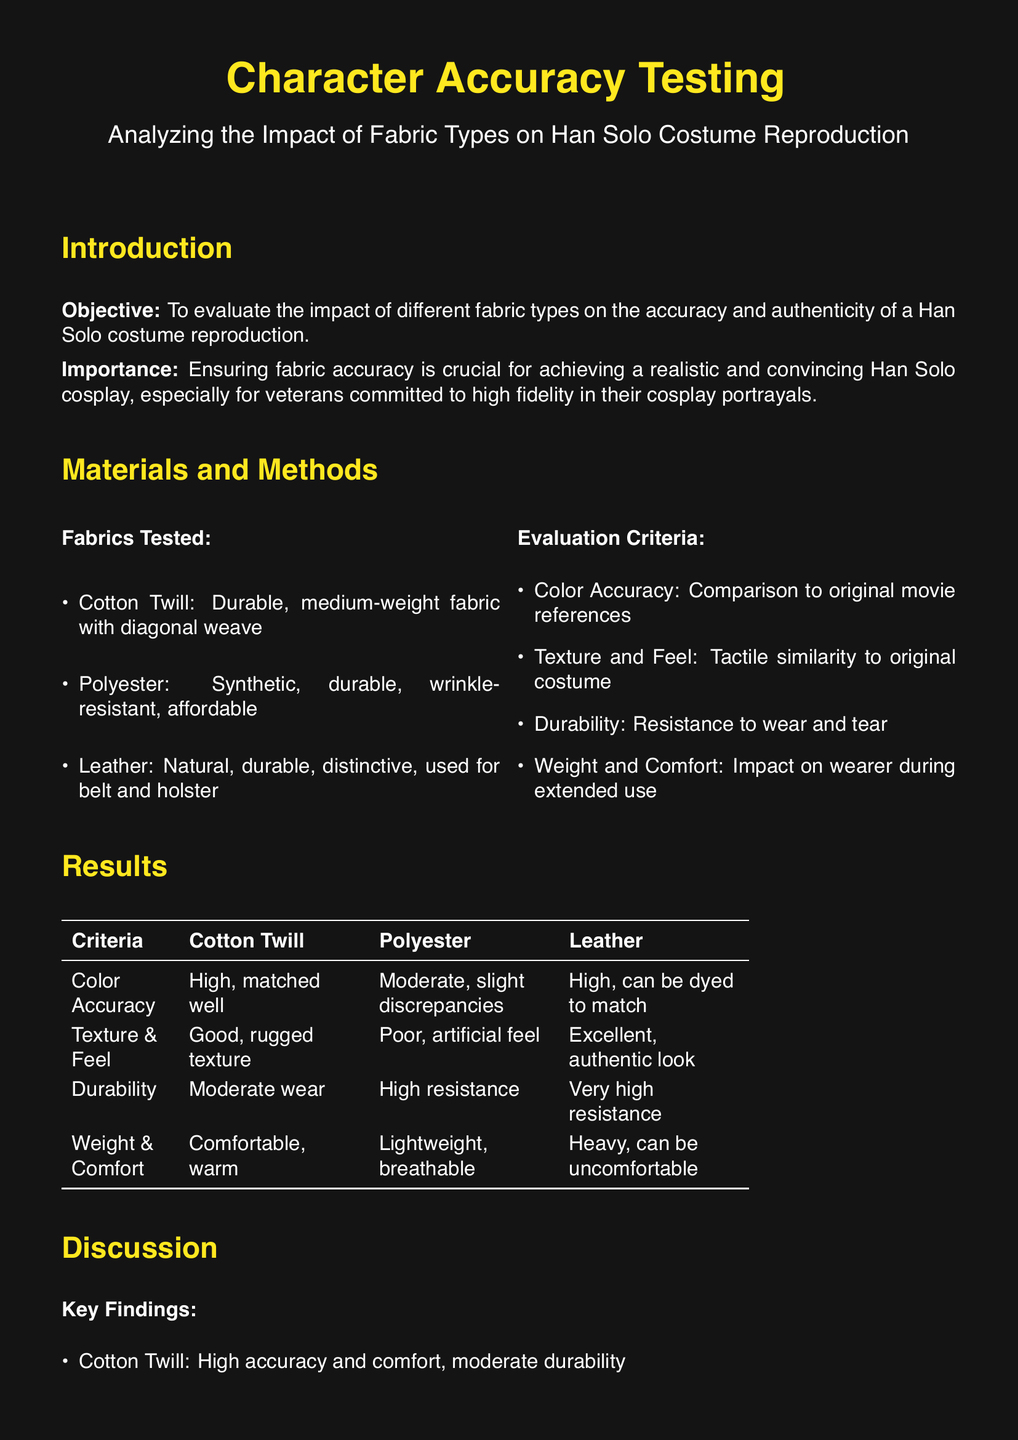What is the objective of the study? The objective of the study is to evaluate the impact of different fabric types on the accuracy and authenticity of a Han Solo costume reproduction.
Answer: To evaluate the impact of different fabric types on the accuracy and authenticity of a Han Solo costume reproduction What fabric type was identified as having poor texture and feel? The document states that polyester had a poor, artificial feel compared to the other fabrics tested.
Answer: Polyester Which fabric type is recommended for the vest? Based on the results, cotton twill is suggested for the vest due to its balance of accuracy and comfort.
Answer: Cotton twill What is the durability rating of leather according to the results? The document indicates leather has very high resistance to wear, making it superior in durability among the tested fabrics.
Answer: Very high resistance Which movie is referenced in the lab report? The lab report cites "Star Wars: A New Hope" from 1977 as one of its references regarding costume accuracy.
Answer: Star Wars: A New Hope (1977) Which fabric type is lightweight and breathable? The polyester fabric type is described as lightweight and breathable in the results section of the document.
Answer: Polyester What evaluation criteria are used in the study? The evaluation criteria include color accuracy, texture and feel, durability, and weight and comfort.
Answer: Color accuracy, texture and feel, durability, weight and comfort Which fabric is recommended for belts and holsters? According to the conclusion, leather is recommended for belts and holsters due to its authenticity.
Answer: Leather 